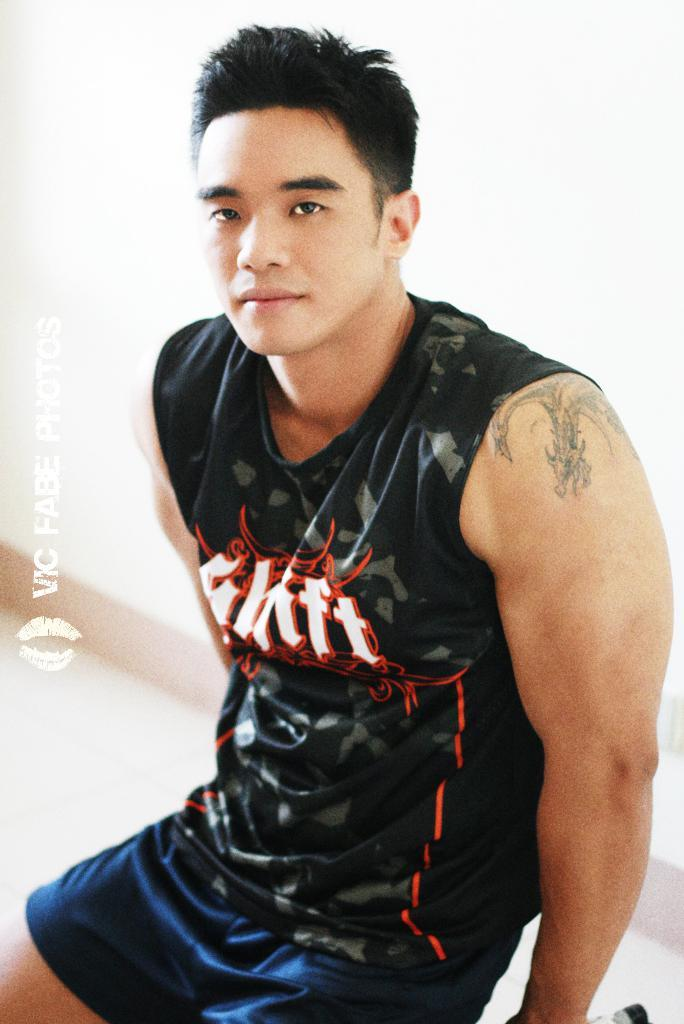<image>
Create a compact narrative representing the image presented. Young man with sleeveless shirt that has Shift on the front. 